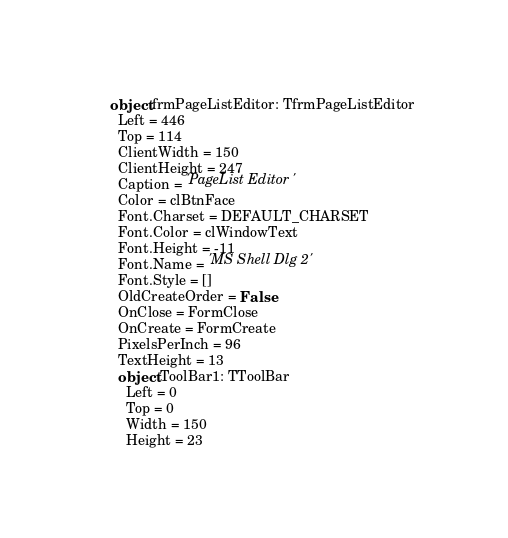<code> <loc_0><loc_0><loc_500><loc_500><_Pascal_>object frmPageListEditor: TfrmPageListEditor
  Left = 446
  Top = 114
  ClientWidth = 150
  ClientHeight = 247
  Caption = 'PageList Editor'
  Color = clBtnFace
  Font.Charset = DEFAULT_CHARSET
  Font.Color = clWindowText
  Font.Height = -11
  Font.Name = 'MS Shell Dlg 2'
  Font.Style = []
  OldCreateOrder = False
  OnClose = FormClose
  OnCreate = FormCreate
  PixelsPerInch = 96
  TextHeight = 13
  object ToolBar1: TToolBar
    Left = 0
    Top = 0
    Width = 150
    Height = 23</code> 